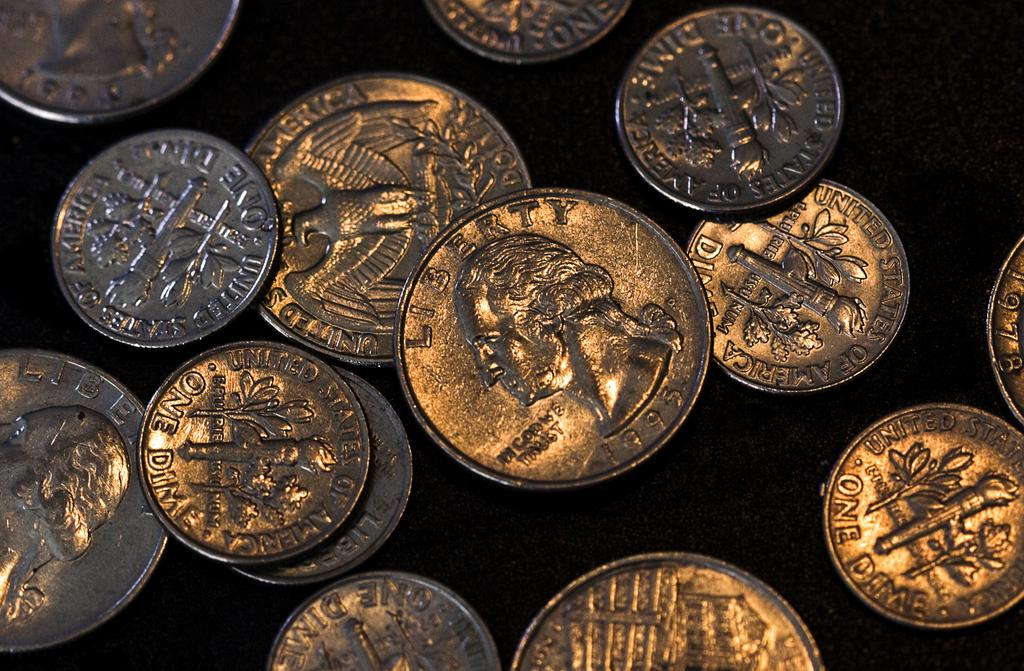Provide a one-sentence caption for the provided image. several American coins reading One Dime and Liberty. 